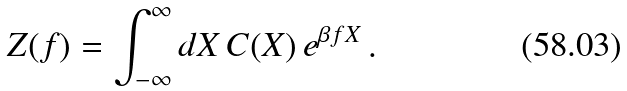Convert formula to latex. <formula><loc_0><loc_0><loc_500><loc_500>Z ( f ) = \int _ { - \infty } ^ { \infty } d X \, C ( X ) \, e ^ { \beta f X } \, .</formula> 